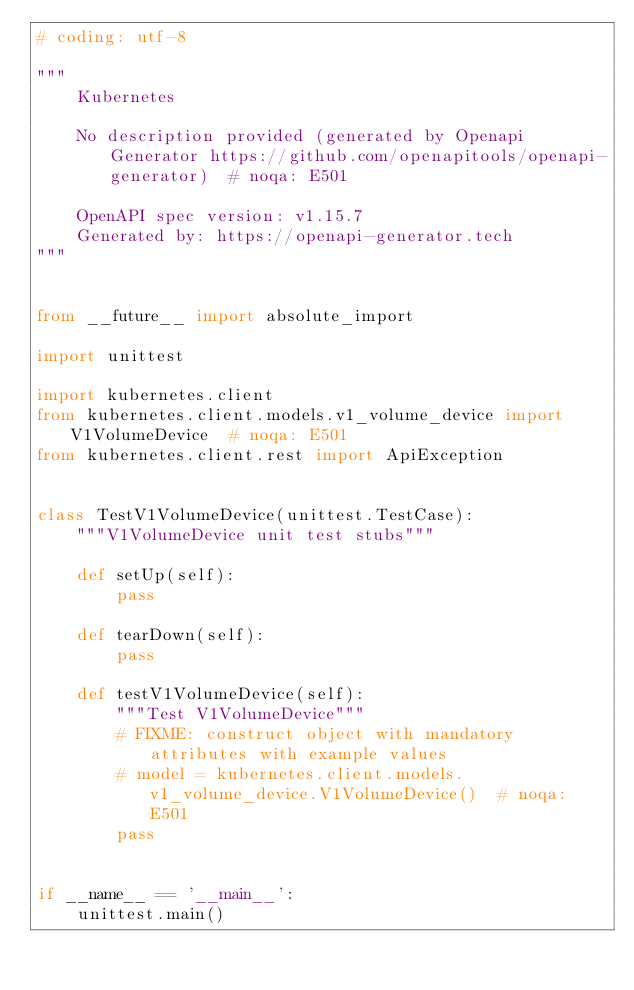<code> <loc_0><loc_0><loc_500><loc_500><_Python_># coding: utf-8

"""
    Kubernetes

    No description provided (generated by Openapi Generator https://github.com/openapitools/openapi-generator)  # noqa: E501

    OpenAPI spec version: v1.15.7
    Generated by: https://openapi-generator.tech
"""


from __future__ import absolute_import

import unittest

import kubernetes.client
from kubernetes.client.models.v1_volume_device import V1VolumeDevice  # noqa: E501
from kubernetes.client.rest import ApiException


class TestV1VolumeDevice(unittest.TestCase):
    """V1VolumeDevice unit test stubs"""

    def setUp(self):
        pass

    def tearDown(self):
        pass

    def testV1VolumeDevice(self):
        """Test V1VolumeDevice"""
        # FIXME: construct object with mandatory attributes with example values
        # model = kubernetes.client.models.v1_volume_device.V1VolumeDevice()  # noqa: E501
        pass


if __name__ == '__main__':
    unittest.main()
</code> 